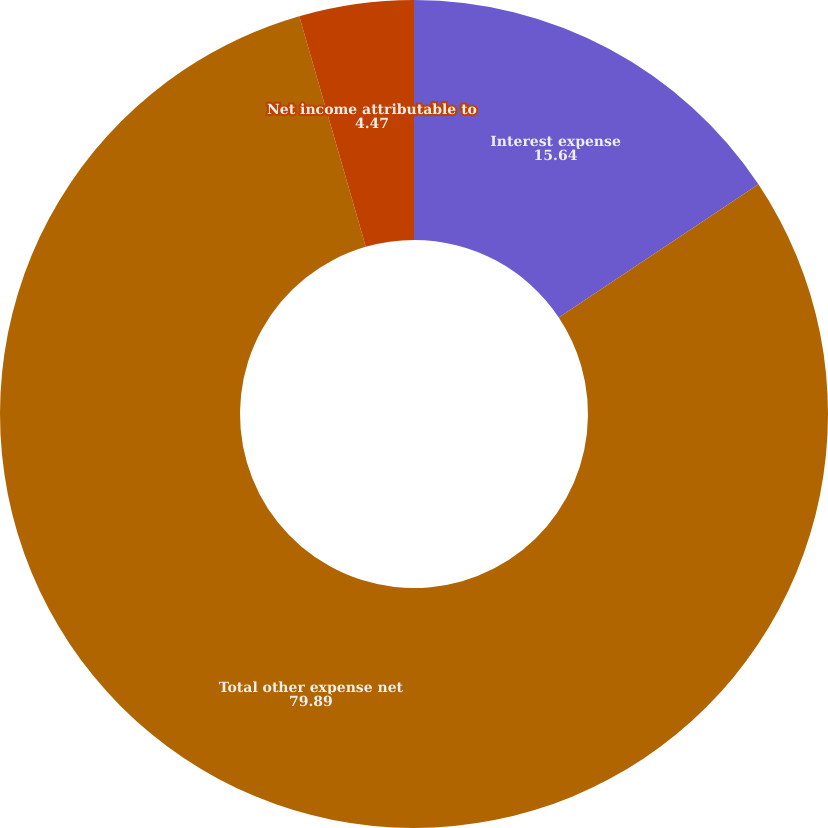Convert chart to OTSL. <chart><loc_0><loc_0><loc_500><loc_500><pie_chart><fcel>Interest expense<fcel>Total other expense net<fcel>Net income attributable to<nl><fcel>15.64%<fcel>79.89%<fcel>4.47%<nl></chart> 